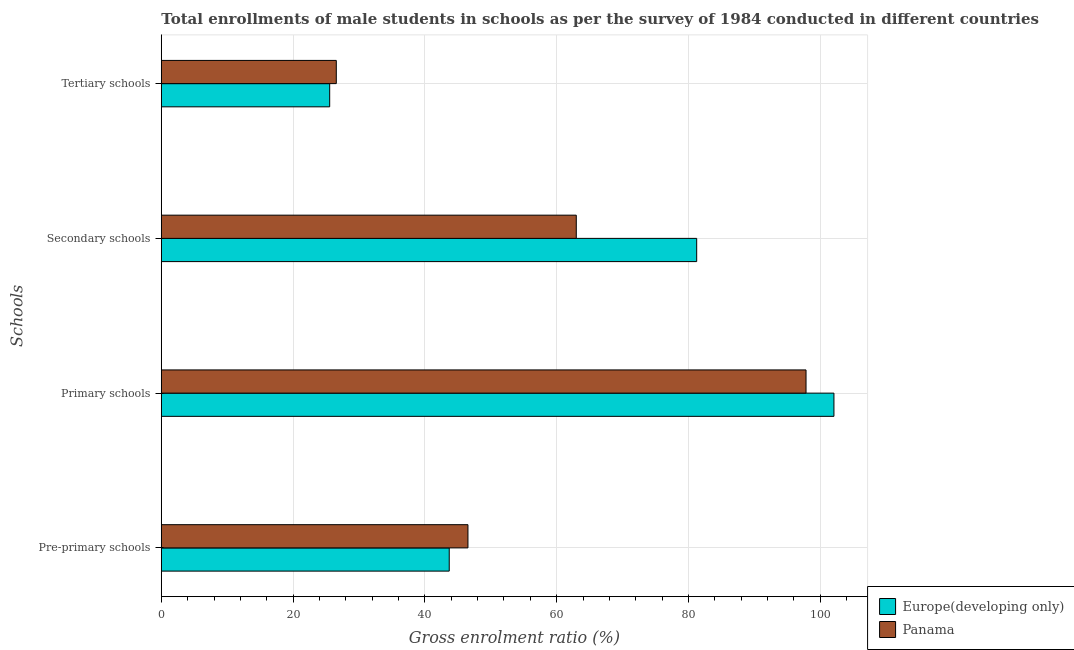How many different coloured bars are there?
Your response must be concise. 2. Are the number of bars per tick equal to the number of legend labels?
Make the answer very short. Yes. Are the number of bars on each tick of the Y-axis equal?
Your answer should be very brief. Yes. How many bars are there on the 1st tick from the top?
Offer a very short reply. 2. How many bars are there on the 1st tick from the bottom?
Your answer should be very brief. 2. What is the label of the 4th group of bars from the top?
Keep it short and to the point. Pre-primary schools. What is the gross enrolment ratio(male) in pre-primary schools in Panama?
Your answer should be compact. 46.53. Across all countries, what is the maximum gross enrolment ratio(male) in tertiary schools?
Your response must be concise. 26.55. Across all countries, what is the minimum gross enrolment ratio(male) in primary schools?
Your answer should be compact. 97.83. In which country was the gross enrolment ratio(male) in tertiary schools maximum?
Offer a terse response. Panama. In which country was the gross enrolment ratio(male) in tertiary schools minimum?
Give a very brief answer. Europe(developing only). What is the total gross enrolment ratio(male) in pre-primary schools in the graph?
Offer a very short reply. 90.22. What is the difference between the gross enrolment ratio(male) in primary schools in Europe(developing only) and that in Panama?
Provide a short and direct response. 4.24. What is the difference between the gross enrolment ratio(male) in pre-primary schools in Europe(developing only) and the gross enrolment ratio(male) in primary schools in Panama?
Provide a succinct answer. -54.14. What is the average gross enrolment ratio(male) in primary schools per country?
Keep it short and to the point. 99.95. What is the difference between the gross enrolment ratio(male) in tertiary schools and gross enrolment ratio(male) in secondary schools in Europe(developing only)?
Offer a very short reply. -55.69. In how many countries, is the gross enrolment ratio(male) in secondary schools greater than 96 %?
Provide a short and direct response. 0. What is the ratio of the gross enrolment ratio(male) in pre-primary schools in Panama to that in Europe(developing only)?
Your answer should be very brief. 1.07. Is the difference between the gross enrolment ratio(male) in tertiary schools in Europe(developing only) and Panama greater than the difference between the gross enrolment ratio(male) in primary schools in Europe(developing only) and Panama?
Your answer should be very brief. No. What is the difference between the highest and the second highest gross enrolment ratio(male) in primary schools?
Offer a terse response. 4.24. What is the difference between the highest and the lowest gross enrolment ratio(male) in pre-primary schools?
Offer a very short reply. 2.84. In how many countries, is the gross enrolment ratio(male) in tertiary schools greater than the average gross enrolment ratio(male) in tertiary schools taken over all countries?
Ensure brevity in your answer.  1. Is the sum of the gross enrolment ratio(male) in tertiary schools in Panama and Europe(developing only) greater than the maximum gross enrolment ratio(male) in secondary schools across all countries?
Your answer should be compact. No. Is it the case that in every country, the sum of the gross enrolment ratio(male) in tertiary schools and gross enrolment ratio(male) in secondary schools is greater than the sum of gross enrolment ratio(male) in primary schools and gross enrolment ratio(male) in pre-primary schools?
Ensure brevity in your answer.  No. What does the 1st bar from the top in Secondary schools represents?
Keep it short and to the point. Panama. What does the 2nd bar from the bottom in Tertiary schools represents?
Ensure brevity in your answer.  Panama. How many bars are there?
Keep it short and to the point. 8. Are all the bars in the graph horizontal?
Your response must be concise. Yes. What is the difference between two consecutive major ticks on the X-axis?
Your answer should be very brief. 20. Where does the legend appear in the graph?
Offer a terse response. Bottom right. How many legend labels are there?
Give a very brief answer. 2. What is the title of the graph?
Offer a very short reply. Total enrollments of male students in schools as per the survey of 1984 conducted in different countries. Does "Russian Federation" appear as one of the legend labels in the graph?
Keep it short and to the point. No. What is the label or title of the X-axis?
Provide a short and direct response. Gross enrolment ratio (%). What is the label or title of the Y-axis?
Provide a succinct answer. Schools. What is the Gross enrolment ratio (%) of Europe(developing only) in Pre-primary schools?
Provide a succinct answer. 43.69. What is the Gross enrolment ratio (%) in Panama in Pre-primary schools?
Offer a very short reply. 46.53. What is the Gross enrolment ratio (%) in Europe(developing only) in Primary schools?
Provide a short and direct response. 102.07. What is the Gross enrolment ratio (%) of Panama in Primary schools?
Provide a succinct answer. 97.83. What is the Gross enrolment ratio (%) of Europe(developing only) in Secondary schools?
Ensure brevity in your answer.  81.24. What is the Gross enrolment ratio (%) in Panama in Secondary schools?
Provide a short and direct response. 62.97. What is the Gross enrolment ratio (%) in Europe(developing only) in Tertiary schools?
Provide a short and direct response. 25.55. What is the Gross enrolment ratio (%) of Panama in Tertiary schools?
Your response must be concise. 26.55. Across all Schools, what is the maximum Gross enrolment ratio (%) in Europe(developing only)?
Offer a very short reply. 102.07. Across all Schools, what is the maximum Gross enrolment ratio (%) in Panama?
Offer a terse response. 97.83. Across all Schools, what is the minimum Gross enrolment ratio (%) in Europe(developing only)?
Your response must be concise. 25.55. Across all Schools, what is the minimum Gross enrolment ratio (%) in Panama?
Provide a short and direct response. 26.55. What is the total Gross enrolment ratio (%) of Europe(developing only) in the graph?
Your answer should be compact. 252.55. What is the total Gross enrolment ratio (%) in Panama in the graph?
Provide a succinct answer. 233.89. What is the difference between the Gross enrolment ratio (%) in Europe(developing only) in Pre-primary schools and that in Primary schools?
Make the answer very short. -58.38. What is the difference between the Gross enrolment ratio (%) of Panama in Pre-primary schools and that in Primary schools?
Offer a terse response. -51.3. What is the difference between the Gross enrolment ratio (%) in Europe(developing only) in Pre-primary schools and that in Secondary schools?
Your answer should be very brief. -37.55. What is the difference between the Gross enrolment ratio (%) of Panama in Pre-primary schools and that in Secondary schools?
Offer a terse response. -16.44. What is the difference between the Gross enrolment ratio (%) in Europe(developing only) in Pre-primary schools and that in Tertiary schools?
Ensure brevity in your answer.  18.14. What is the difference between the Gross enrolment ratio (%) of Panama in Pre-primary schools and that in Tertiary schools?
Offer a very short reply. 19.98. What is the difference between the Gross enrolment ratio (%) in Europe(developing only) in Primary schools and that in Secondary schools?
Provide a short and direct response. 20.83. What is the difference between the Gross enrolment ratio (%) in Panama in Primary schools and that in Secondary schools?
Offer a terse response. 34.86. What is the difference between the Gross enrolment ratio (%) of Europe(developing only) in Primary schools and that in Tertiary schools?
Provide a succinct answer. 76.52. What is the difference between the Gross enrolment ratio (%) of Panama in Primary schools and that in Tertiary schools?
Provide a short and direct response. 71.28. What is the difference between the Gross enrolment ratio (%) of Europe(developing only) in Secondary schools and that in Tertiary schools?
Ensure brevity in your answer.  55.69. What is the difference between the Gross enrolment ratio (%) in Panama in Secondary schools and that in Tertiary schools?
Offer a very short reply. 36.42. What is the difference between the Gross enrolment ratio (%) in Europe(developing only) in Pre-primary schools and the Gross enrolment ratio (%) in Panama in Primary schools?
Your answer should be very brief. -54.14. What is the difference between the Gross enrolment ratio (%) in Europe(developing only) in Pre-primary schools and the Gross enrolment ratio (%) in Panama in Secondary schools?
Offer a very short reply. -19.28. What is the difference between the Gross enrolment ratio (%) in Europe(developing only) in Pre-primary schools and the Gross enrolment ratio (%) in Panama in Tertiary schools?
Your answer should be compact. 17.14. What is the difference between the Gross enrolment ratio (%) in Europe(developing only) in Primary schools and the Gross enrolment ratio (%) in Panama in Secondary schools?
Give a very brief answer. 39.1. What is the difference between the Gross enrolment ratio (%) of Europe(developing only) in Primary schools and the Gross enrolment ratio (%) of Panama in Tertiary schools?
Provide a short and direct response. 75.52. What is the difference between the Gross enrolment ratio (%) in Europe(developing only) in Secondary schools and the Gross enrolment ratio (%) in Panama in Tertiary schools?
Your answer should be very brief. 54.69. What is the average Gross enrolment ratio (%) in Europe(developing only) per Schools?
Your answer should be very brief. 63.14. What is the average Gross enrolment ratio (%) in Panama per Schools?
Offer a very short reply. 58.47. What is the difference between the Gross enrolment ratio (%) of Europe(developing only) and Gross enrolment ratio (%) of Panama in Pre-primary schools?
Your answer should be very brief. -2.84. What is the difference between the Gross enrolment ratio (%) in Europe(developing only) and Gross enrolment ratio (%) in Panama in Primary schools?
Your answer should be very brief. 4.24. What is the difference between the Gross enrolment ratio (%) of Europe(developing only) and Gross enrolment ratio (%) of Panama in Secondary schools?
Make the answer very short. 18.27. What is the difference between the Gross enrolment ratio (%) of Europe(developing only) and Gross enrolment ratio (%) of Panama in Tertiary schools?
Make the answer very short. -1. What is the ratio of the Gross enrolment ratio (%) of Europe(developing only) in Pre-primary schools to that in Primary schools?
Offer a very short reply. 0.43. What is the ratio of the Gross enrolment ratio (%) in Panama in Pre-primary schools to that in Primary schools?
Offer a very short reply. 0.48. What is the ratio of the Gross enrolment ratio (%) in Europe(developing only) in Pre-primary schools to that in Secondary schools?
Provide a succinct answer. 0.54. What is the ratio of the Gross enrolment ratio (%) of Panama in Pre-primary schools to that in Secondary schools?
Keep it short and to the point. 0.74. What is the ratio of the Gross enrolment ratio (%) of Europe(developing only) in Pre-primary schools to that in Tertiary schools?
Provide a short and direct response. 1.71. What is the ratio of the Gross enrolment ratio (%) in Panama in Pre-primary schools to that in Tertiary schools?
Make the answer very short. 1.75. What is the ratio of the Gross enrolment ratio (%) of Europe(developing only) in Primary schools to that in Secondary schools?
Offer a very short reply. 1.26. What is the ratio of the Gross enrolment ratio (%) in Panama in Primary schools to that in Secondary schools?
Offer a very short reply. 1.55. What is the ratio of the Gross enrolment ratio (%) of Europe(developing only) in Primary schools to that in Tertiary schools?
Provide a succinct answer. 3.99. What is the ratio of the Gross enrolment ratio (%) of Panama in Primary schools to that in Tertiary schools?
Offer a very short reply. 3.68. What is the ratio of the Gross enrolment ratio (%) in Europe(developing only) in Secondary schools to that in Tertiary schools?
Keep it short and to the point. 3.18. What is the ratio of the Gross enrolment ratio (%) in Panama in Secondary schools to that in Tertiary schools?
Ensure brevity in your answer.  2.37. What is the difference between the highest and the second highest Gross enrolment ratio (%) in Europe(developing only)?
Your response must be concise. 20.83. What is the difference between the highest and the second highest Gross enrolment ratio (%) in Panama?
Make the answer very short. 34.86. What is the difference between the highest and the lowest Gross enrolment ratio (%) in Europe(developing only)?
Offer a terse response. 76.52. What is the difference between the highest and the lowest Gross enrolment ratio (%) of Panama?
Offer a terse response. 71.28. 